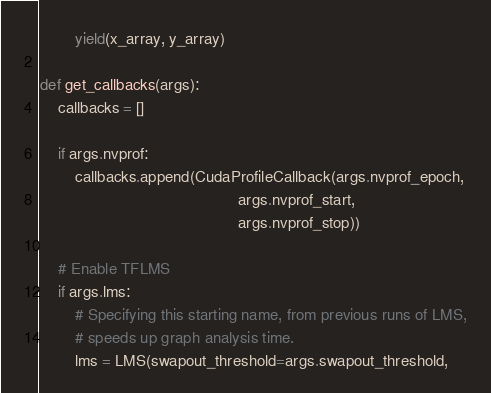Convert code to text. <code><loc_0><loc_0><loc_500><loc_500><_Python_>        yield(x_array, y_array)

def get_callbacks(args):
    callbacks = []

    if args.nvprof:
        callbacks.append(CudaProfileCallback(args.nvprof_epoch,
                                             args.nvprof_start,
                                             args.nvprof_stop))

    # Enable TFLMS
    if args.lms:
        # Specifying this starting name, from previous runs of LMS,
        # speeds up graph analysis time.
        lms = LMS(swapout_threshold=args.swapout_threshold,</code> 